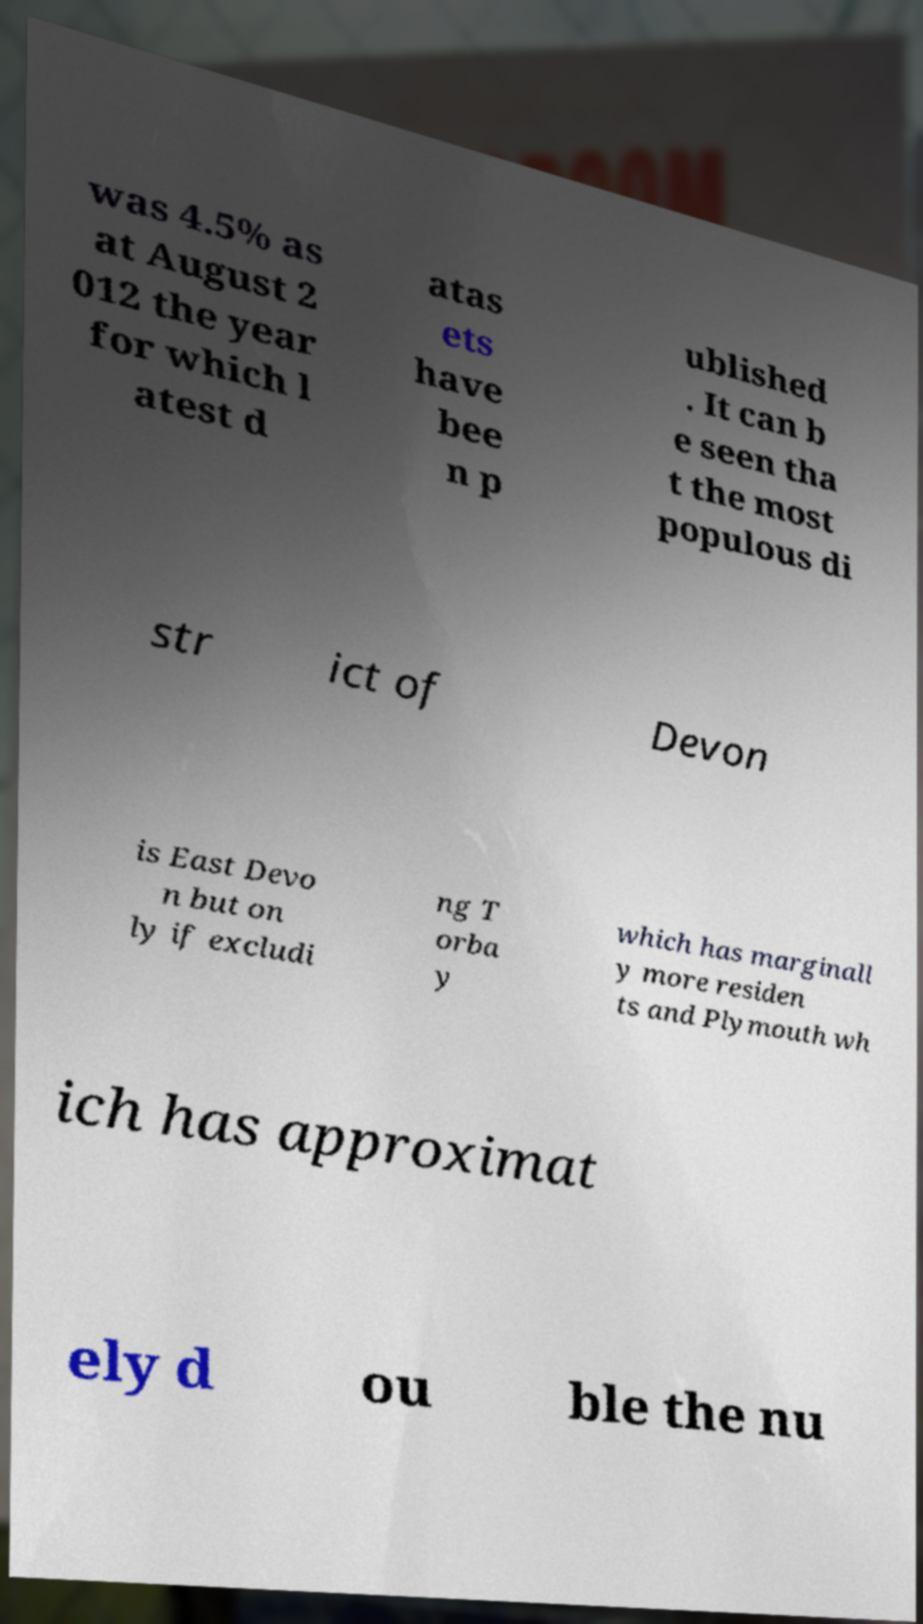What messages or text are displayed in this image? I need them in a readable, typed format. was 4.5% as at August 2 012 the year for which l atest d atas ets have bee n p ublished . It can b e seen tha t the most populous di str ict of Devon is East Devo n but on ly if excludi ng T orba y which has marginall y more residen ts and Plymouth wh ich has approximat ely d ou ble the nu 